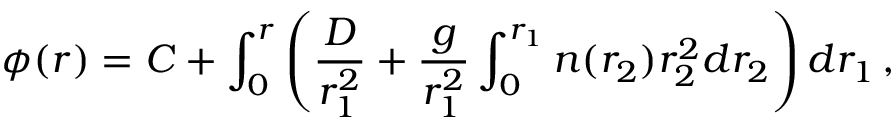Convert formula to latex. <formula><loc_0><loc_0><loc_500><loc_500>\phi ( r ) = C + \int _ { 0 } ^ { r } \left ( \frac { D } r _ { 1 } ^ { 2 } } + \frac { g } r _ { 1 } ^ { 2 } } \int _ { 0 } ^ { r _ { 1 } } n ( r _ { 2 } ) r _ { 2 } ^ { 2 } d r _ { 2 } \right ) d r _ { 1 } \, ,</formula> 